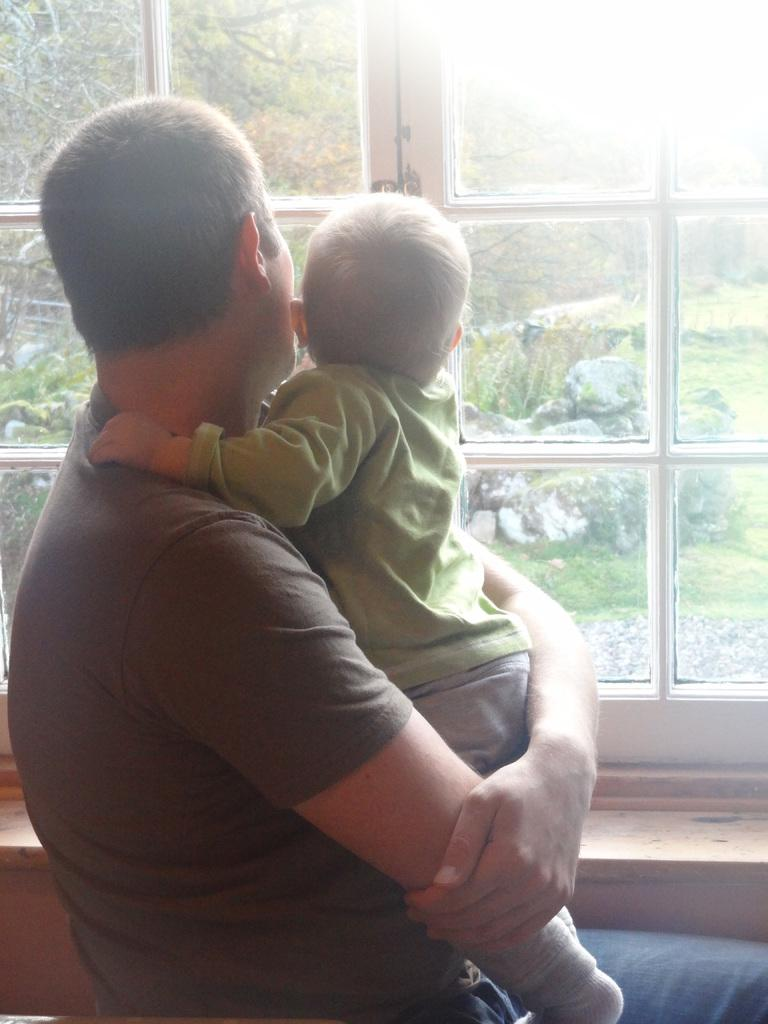What is the person in the image doing? The person is holding a baby in the image. What can be seen in the background of the image? There is a glass window and trees in green color in the background of the image. What type of surface is visible in the image? There are stones visible in the image. How many dogs are visible in the image? There are no dogs present in the image. What type of error can be seen in the baby's mouth in the image? There is no error visible in the baby's mouth in the image, as there are no mouths mentioned in the facts. 